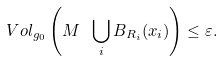Convert formula to latex. <formula><loc_0><loc_0><loc_500><loc_500>\ V o l _ { g _ { 0 } } \left ( M \ \bigcup _ { i } B _ { R _ { i } } ( x _ { i } ) \right ) \leq \varepsilon .</formula> 